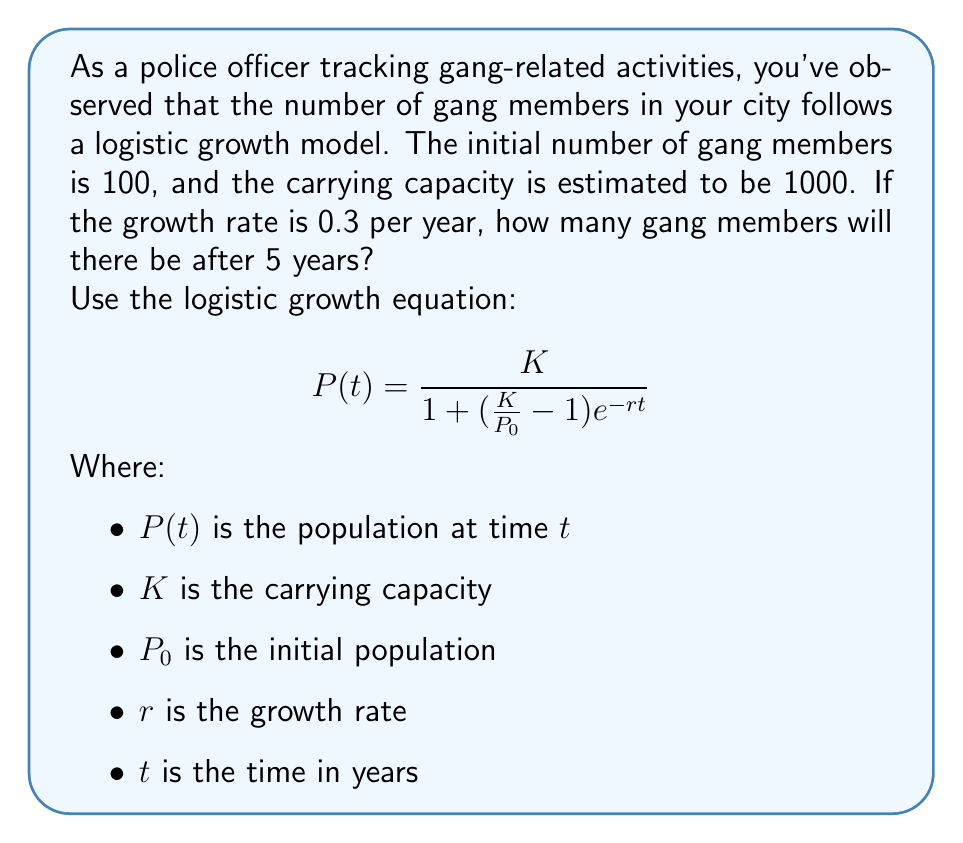Could you help me with this problem? To solve this problem, we'll use the given logistic growth equation and plug in the known values:

1. $K = 1000$ (carrying capacity)
2. $P_0 = 100$ (initial population)
3. $r = 0.3$ (growth rate per year)
4. $t = 5$ (time in years)

Let's substitute these values into the equation:

$$P(5) = \frac{1000}{1 + (\frac{1000}{100} - 1)e^{-0.3 \cdot 5}}$$

Now, let's solve step by step:

1. Simplify the fraction inside the parentheses:
   $$P(5) = \frac{1000}{1 + (10 - 1)e^{-1.5}}$$

2. Simplify further:
   $$P(5) = \frac{1000}{1 + 9e^{-1.5}}$$

3. Calculate $e^{-1.5}$ (you can use a calculator for this):
   $e^{-1.5} \approx 0.2231$

4. Multiply:
   $$P(5) = \frac{1000}{1 + 9 \cdot 0.2231} = \frac{1000}{1 + 2.0079}$$

5. Add in the denominator:
   $$P(5) = \frac{1000}{3.0079}$$

6. Divide:
   $$P(5) \approx 332.46$$

7. Round to the nearest whole number, as we're dealing with people:
   $$P(5) \approx 332$$

Therefore, after 5 years, there will be approximately 332 gang members in the city.
Answer: 332 gang members 